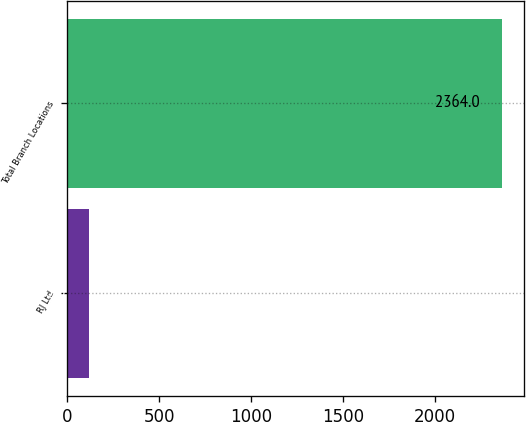<chart> <loc_0><loc_0><loc_500><loc_500><bar_chart><fcel>RJ Ltd<fcel>Total Branch Locations<nl><fcel>115<fcel>2364<nl></chart> 